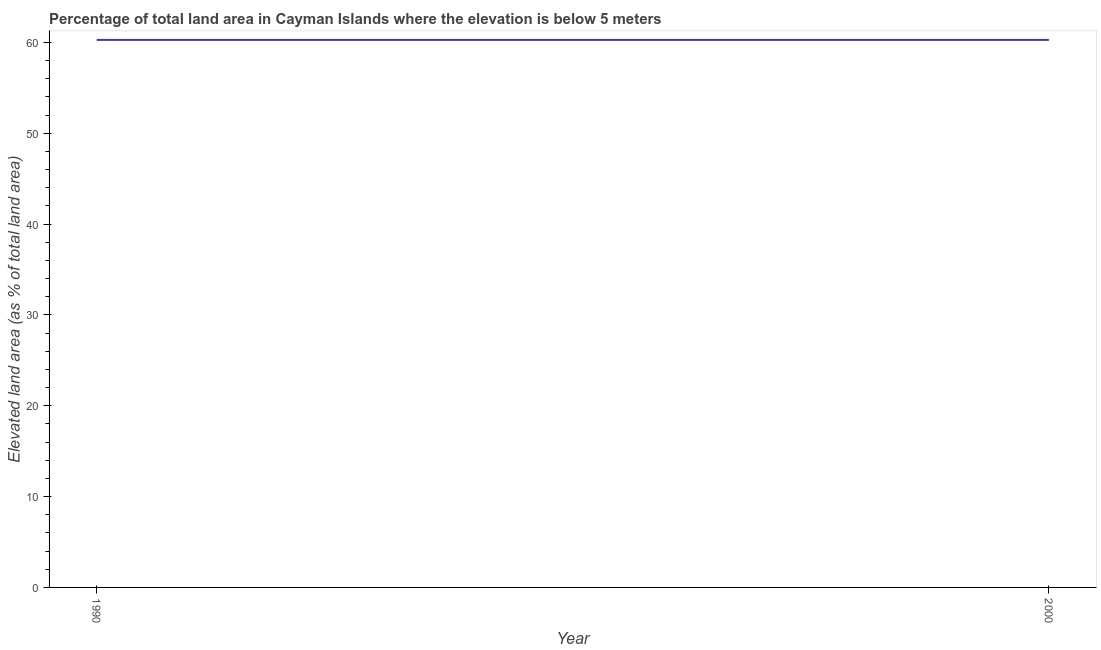What is the total elevated land area in 2000?
Keep it short and to the point. 60.28. Across all years, what is the maximum total elevated land area?
Offer a very short reply. 60.28. Across all years, what is the minimum total elevated land area?
Your answer should be compact. 60.28. What is the sum of the total elevated land area?
Keep it short and to the point. 120.57. What is the difference between the total elevated land area in 1990 and 2000?
Offer a terse response. 0. What is the average total elevated land area per year?
Offer a very short reply. 60.28. What is the median total elevated land area?
Offer a terse response. 60.28. In how many years, is the total elevated land area greater than 10 %?
Offer a terse response. 2. Do a majority of the years between 1990 and 2000 (inclusive) have total elevated land area greater than 46 %?
Offer a terse response. Yes. Is the total elevated land area in 1990 less than that in 2000?
Your answer should be very brief. No. In how many years, is the total elevated land area greater than the average total elevated land area taken over all years?
Make the answer very short. 0. How many lines are there?
Keep it short and to the point. 1. How many years are there in the graph?
Keep it short and to the point. 2. What is the difference between two consecutive major ticks on the Y-axis?
Provide a succinct answer. 10. Does the graph contain grids?
Make the answer very short. No. What is the title of the graph?
Your response must be concise. Percentage of total land area in Cayman Islands where the elevation is below 5 meters. What is the label or title of the Y-axis?
Provide a short and direct response. Elevated land area (as % of total land area). What is the Elevated land area (as % of total land area) of 1990?
Offer a very short reply. 60.28. What is the Elevated land area (as % of total land area) of 2000?
Your response must be concise. 60.28. 